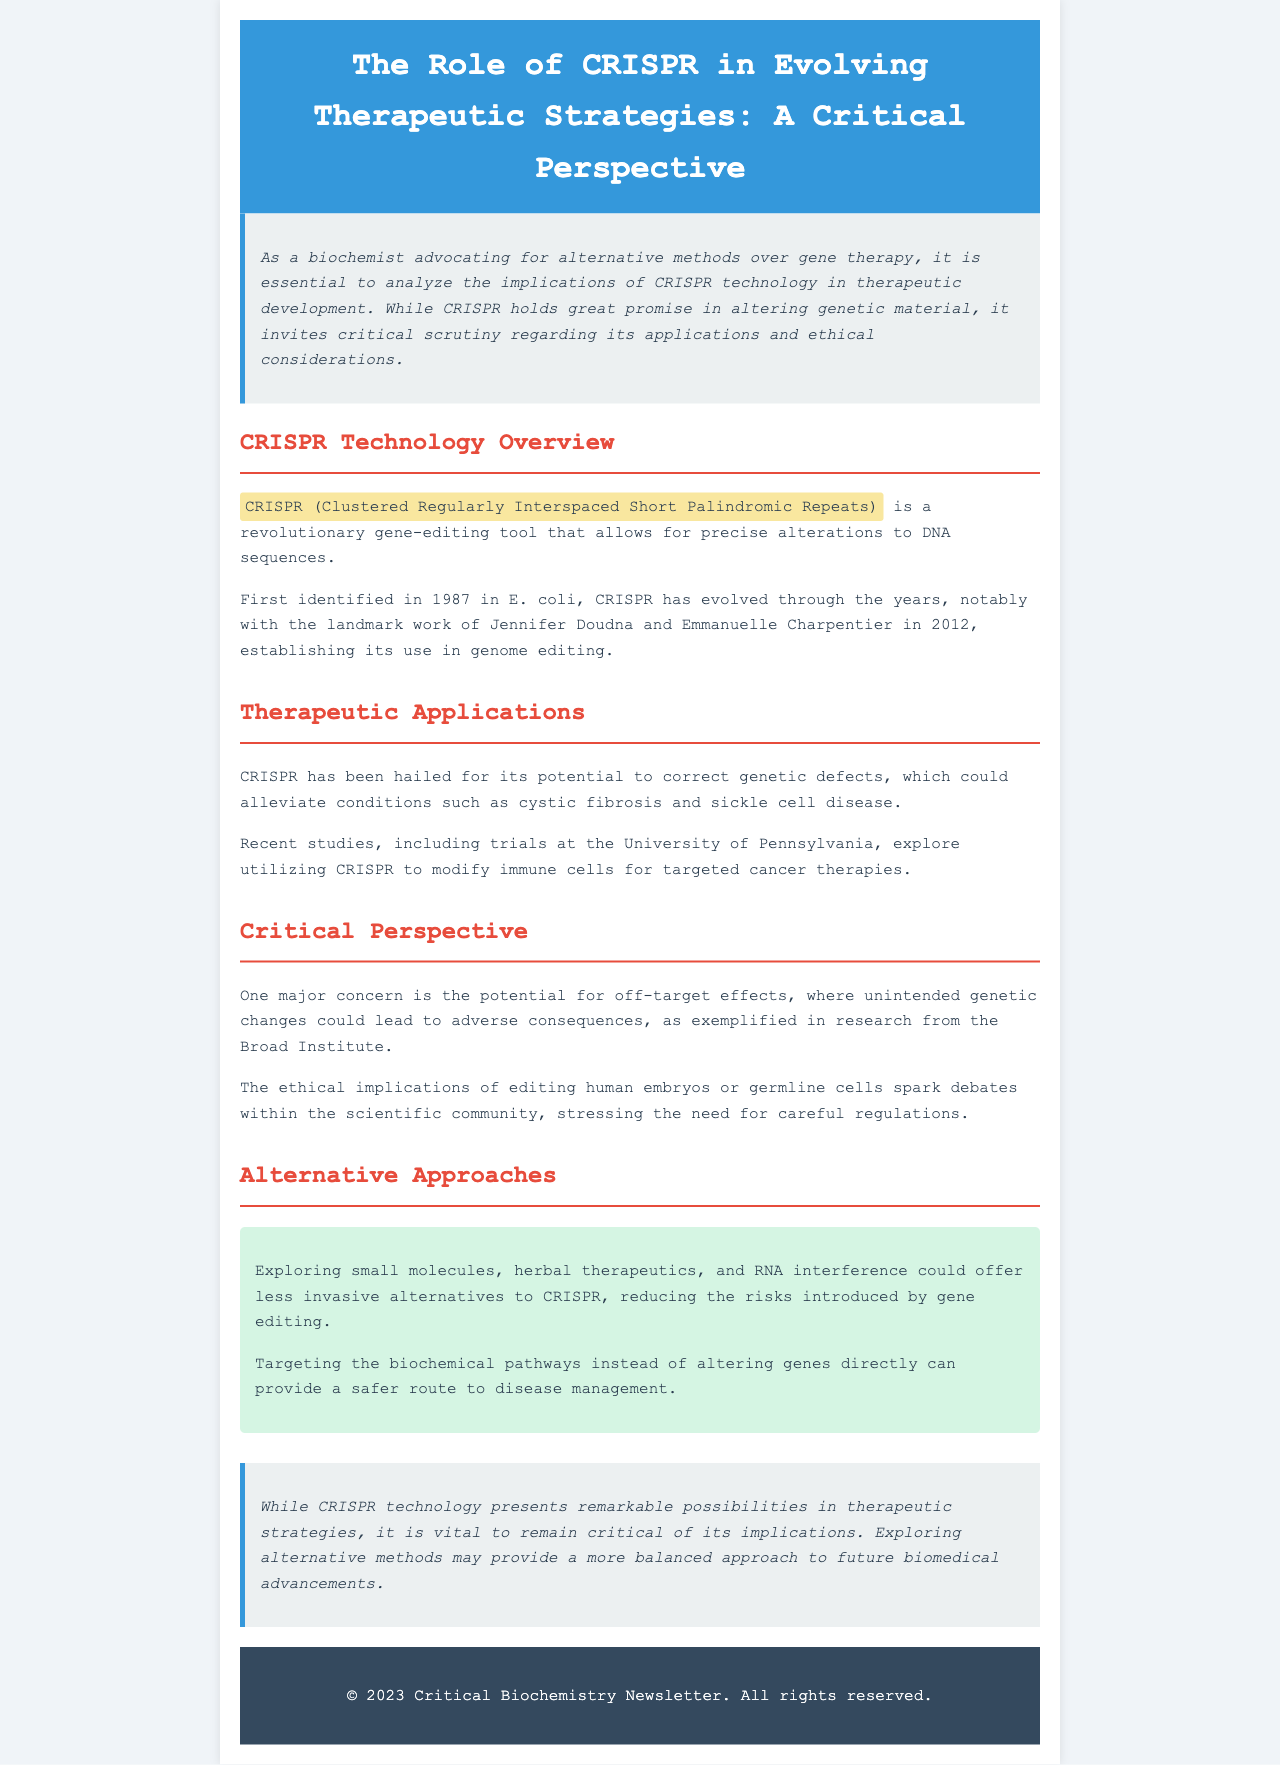What is CRISPR? CRISPR is defined as Clustered Regularly Interspaced Short Palindromic Repeats in the document.
Answer: Clustered Regularly Interspaced Short Palindromic Repeats Who are the key figures behind the development of CRISPR technology? The key figures mentioned for CRISPR's development are Jennifer Doudna and Emmanuelle Charpentier.
Answer: Jennifer Doudna and Emmanuelle Charpentier What condition could CRISPR potentially alleviate? The document states that CRISPR could potentially alleviate cystic fibrosis.
Answer: Cystic fibrosis What are the ethical concerns associated with CRISPR? The ethical concerns mentioned pertain to editing human embryos or germline cells.
Answer: Editing human embryos or germline cells What alternative approaches are suggested in the newsletter? The newsletter suggests exploring small molecules, herbal therapeutics, and RNA interference as alternatives.
Answer: Small molecules, herbal therapeutics, and RNA interference What is a major concern related to off-target effects? The document notes that off-target effects can lead to adverse consequences.
Answer: Adverse consequences What institution is mentioned for studies utilizing CRISPR in cancer therapy? The University of Pennsylvania is the institution referenced for studies in cancer therapy.
Answer: University of Pennsylvania What does the introduction stress about the analysis of CRISPR? The introduction stresses the implications of CRISPR technology in therapeutic development.
Answer: Implications of CRISPR technology in therapeutic development What is the overarching theme of the newsletter? The overarching theme is a critical perspective on CRISPR's role in therapeutic strategies.
Answer: Critical perspective on CRISPR's role in therapeutic strategies 